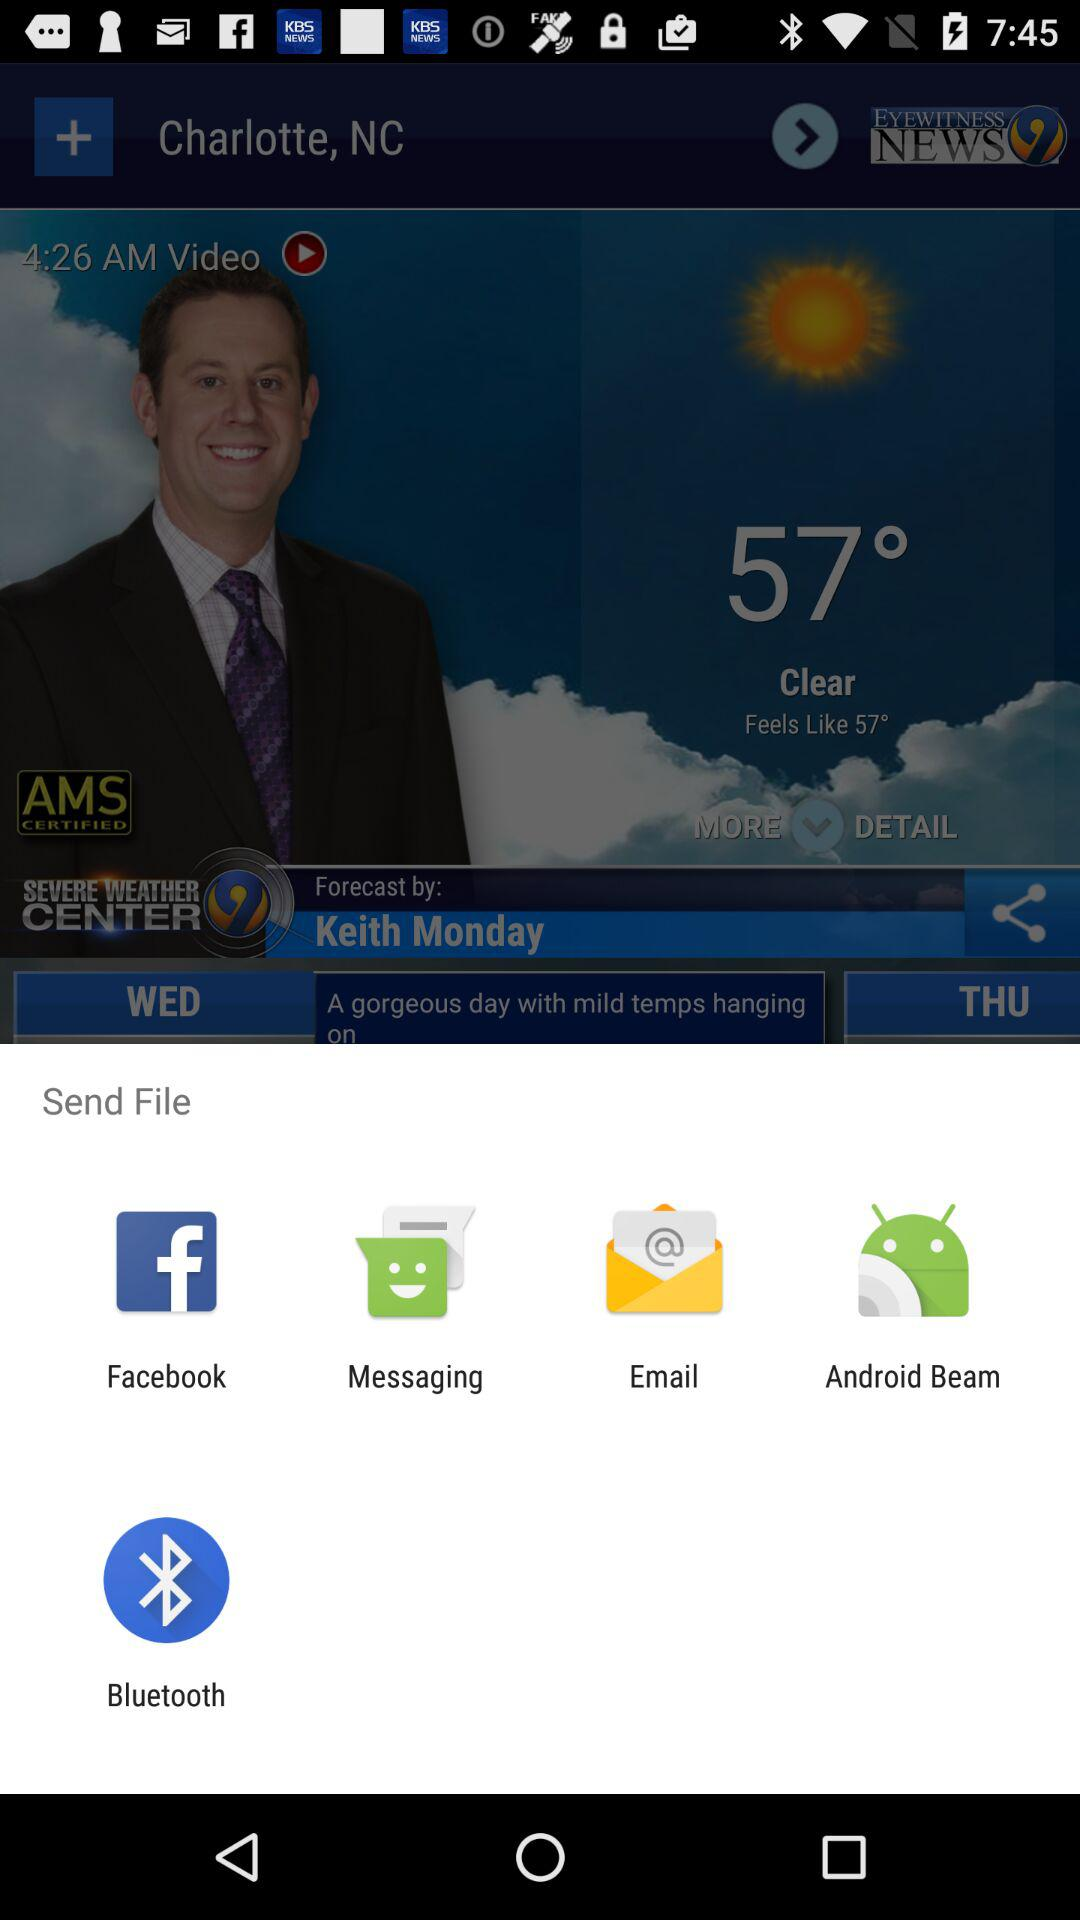What is selected location? The selected location is "Charlotte, NC". 